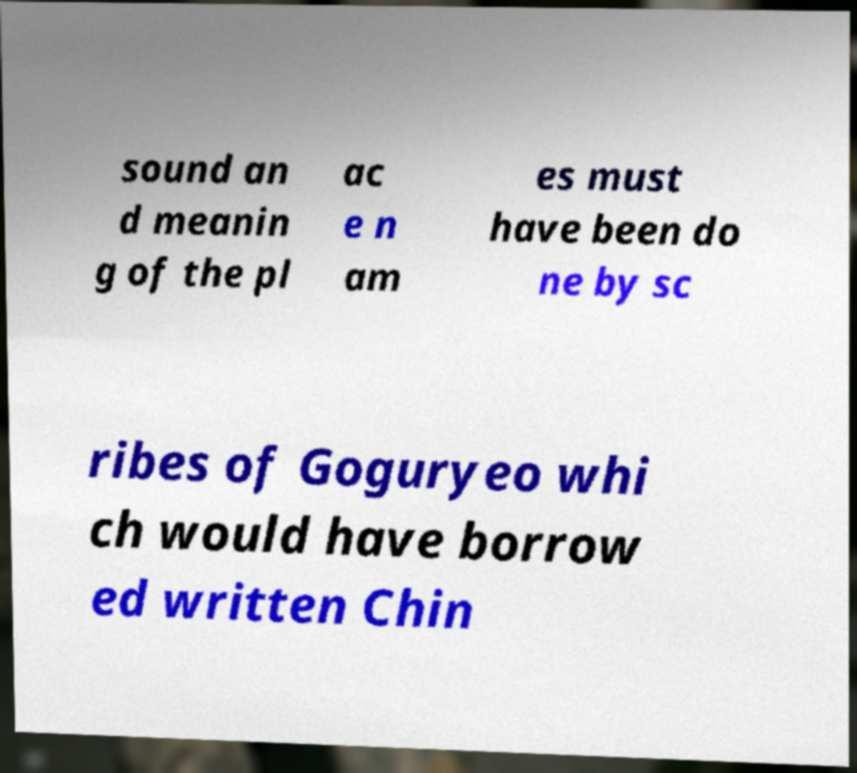For documentation purposes, I need the text within this image transcribed. Could you provide that? sound an d meanin g of the pl ac e n am es must have been do ne by sc ribes of Goguryeo whi ch would have borrow ed written Chin 